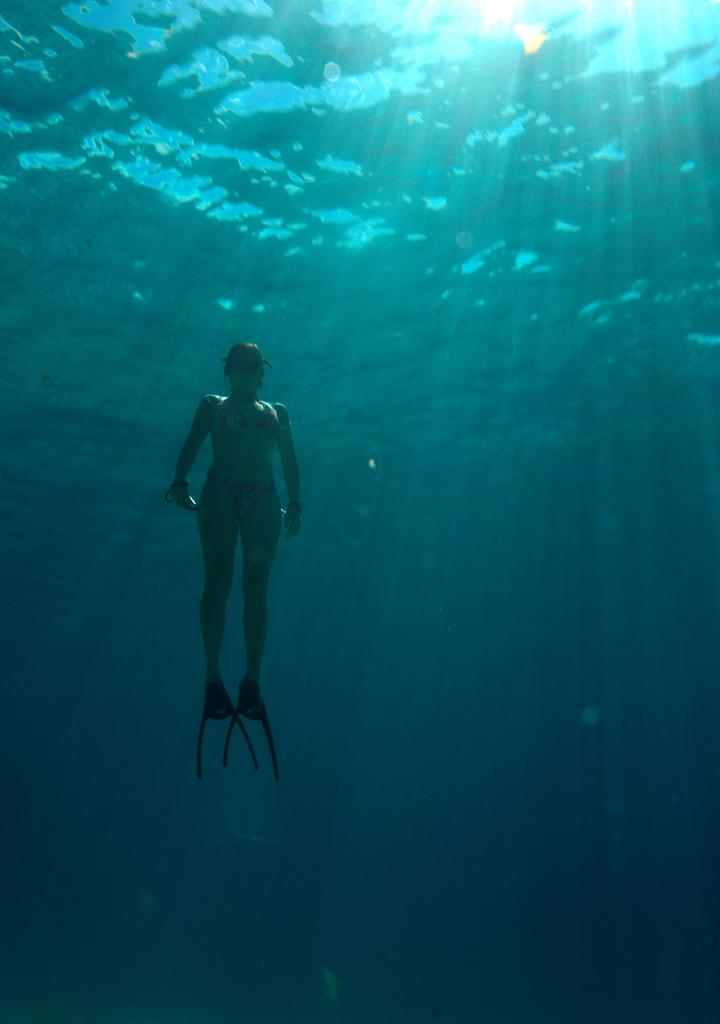What is the main subject of the image? There is a person in the image. Can you describe the person's location in the image? The person is standing inside the water. What songs is the person singing while standing inside the water? There is no information about the person singing any songs in the image. 